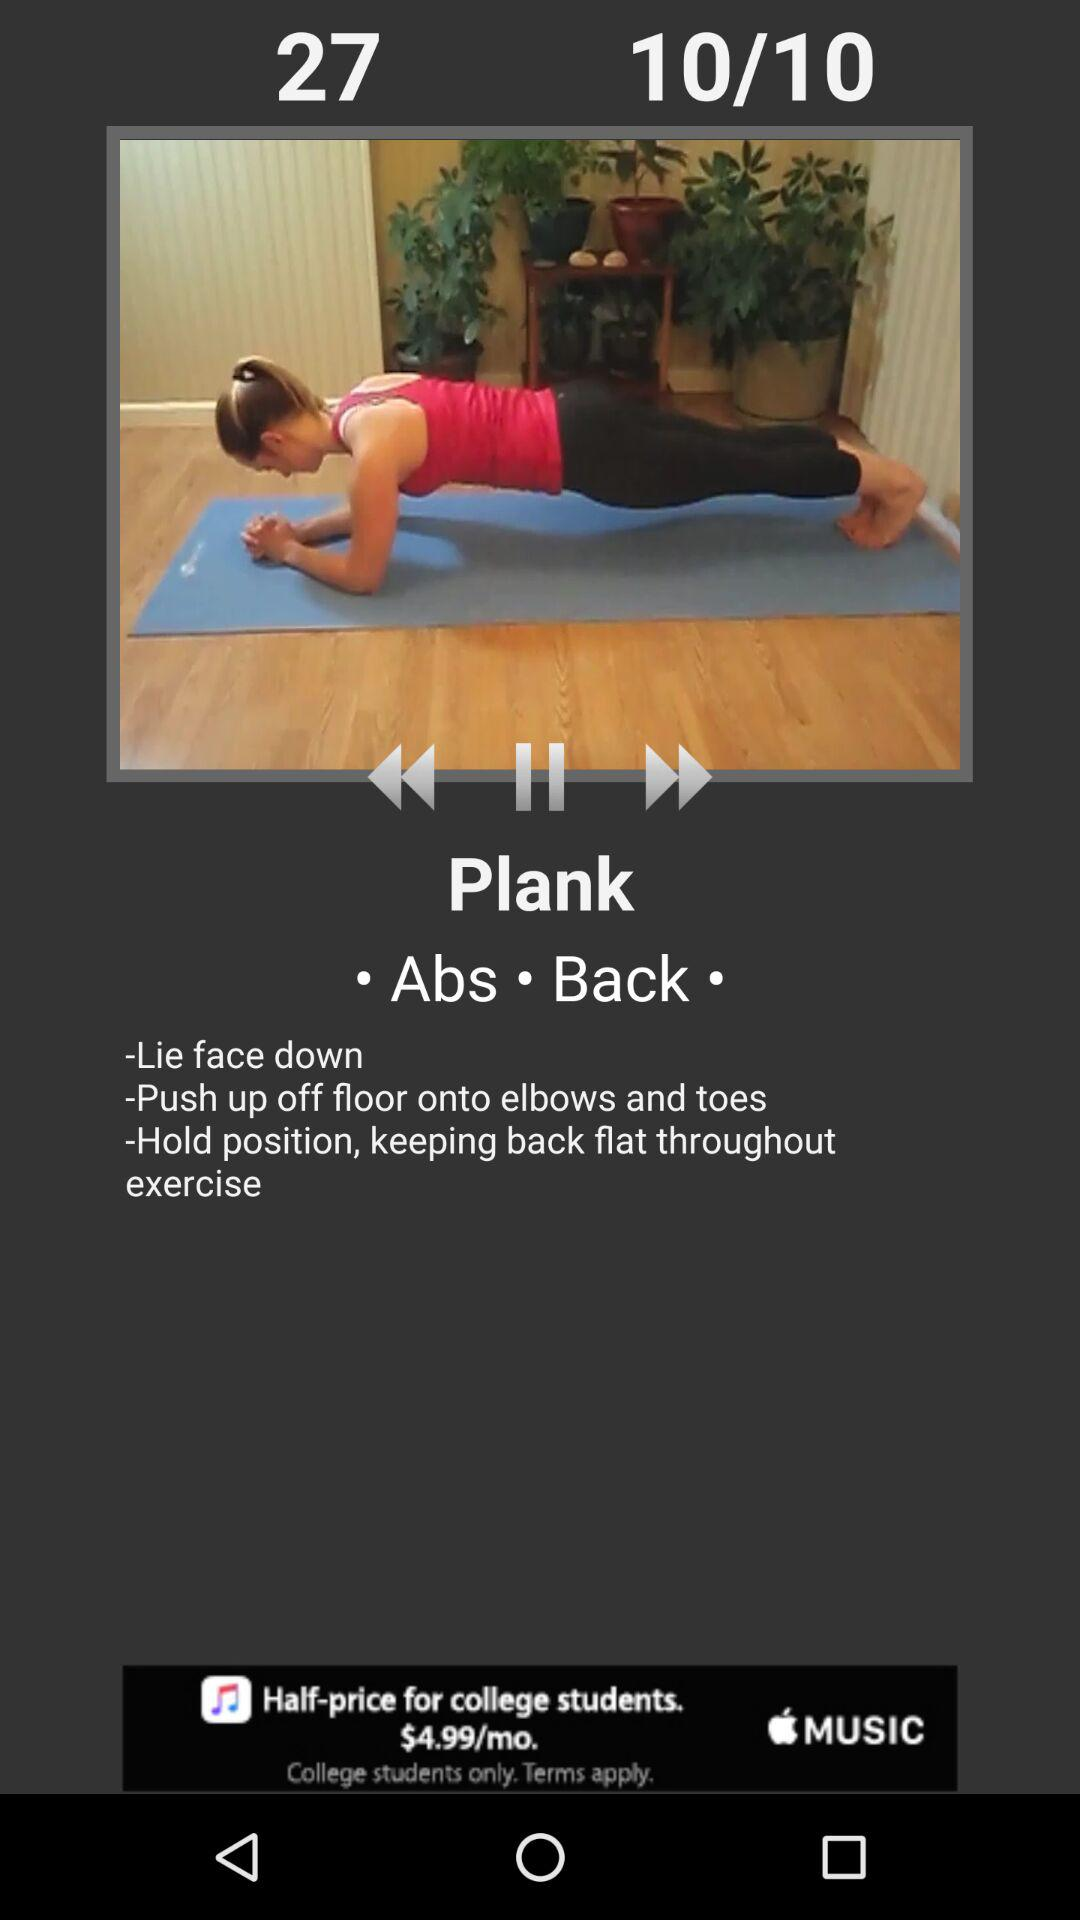How many sections are there in the exercise instructions?
Answer the question using a single word or phrase. 3 